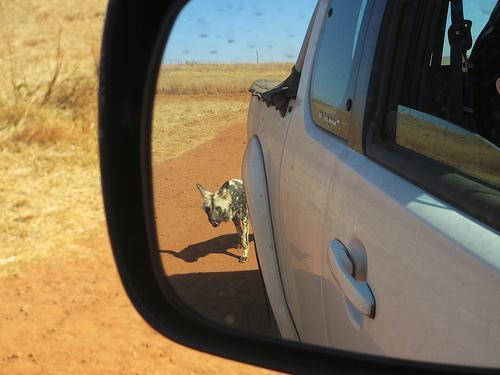How many coyotes are there?
Give a very brief answer. 1. 